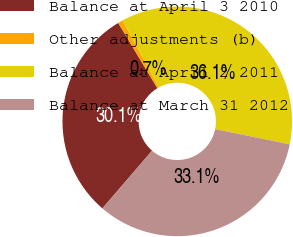<chart> <loc_0><loc_0><loc_500><loc_500><pie_chart><fcel>Balance at April 3 2010<fcel>Other adjustments (b)<fcel>Balance at April 2 2011<fcel>Balance at March 31 2012<nl><fcel>30.09%<fcel>0.7%<fcel>36.11%<fcel>33.1%<nl></chart> 